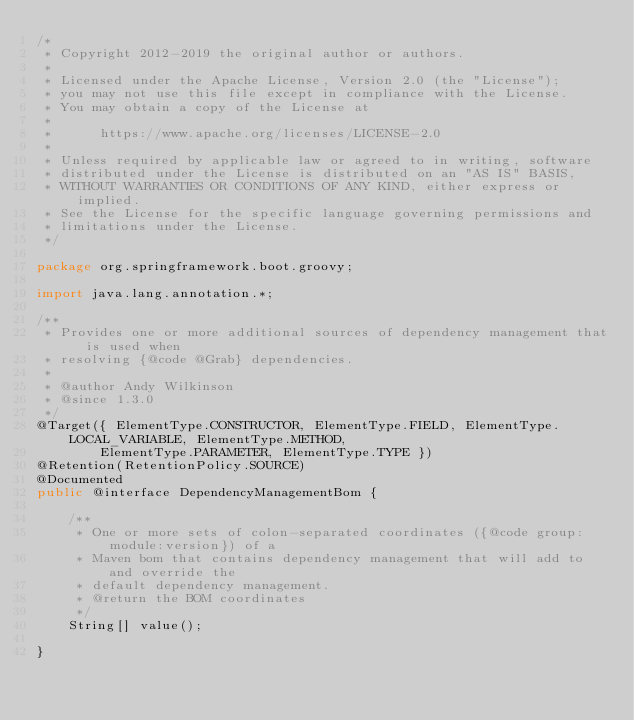<code> <loc_0><loc_0><loc_500><loc_500><_Java_>/*
 * Copyright 2012-2019 the original author or authors.
 *
 * Licensed under the Apache License, Version 2.0 (the "License");
 * you may not use this file except in compliance with the License.
 * You may obtain a copy of the License at
 *
 *      https://www.apache.org/licenses/LICENSE-2.0
 *
 * Unless required by applicable law or agreed to in writing, software
 * distributed under the License is distributed on an "AS IS" BASIS,
 * WITHOUT WARRANTIES OR CONDITIONS OF ANY KIND, either express or implied.
 * See the License for the specific language governing permissions and
 * limitations under the License.
 */

package org.springframework.boot.groovy;

import java.lang.annotation.*;

/**
 * Provides one or more additional sources of dependency management that is used when
 * resolving {@code @Grab} dependencies.
 *
 * @author Andy Wilkinson
 * @since 1.3.0
 */
@Target({ ElementType.CONSTRUCTOR, ElementType.FIELD, ElementType.LOCAL_VARIABLE, ElementType.METHOD,
		ElementType.PARAMETER, ElementType.TYPE })
@Retention(RetentionPolicy.SOURCE)
@Documented
public @interface DependencyManagementBom {

	/**
	 * One or more sets of colon-separated coordinates ({@code group:module:version}) of a
	 * Maven bom that contains dependency management that will add to and override the
	 * default dependency management.
	 * @return the BOM coordinates
	 */
	String[] value();

}
</code> 